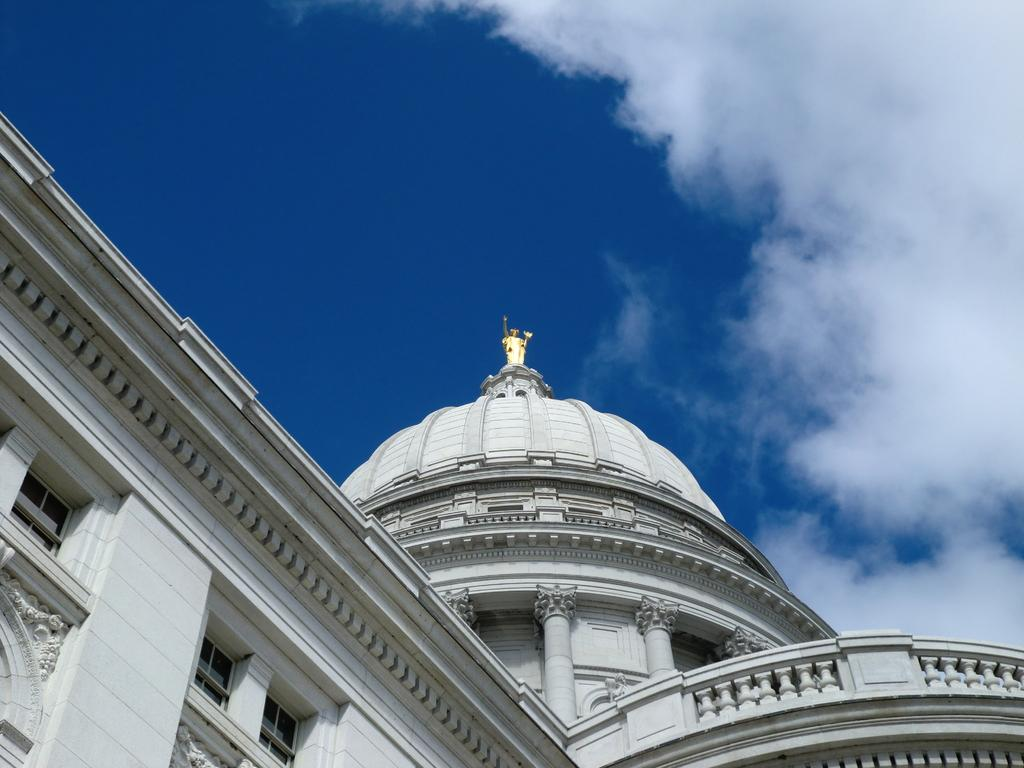What is located on the building in the image? There is a statue on a building in the image. What can be seen in the background of the image? The sky is visible in the background of the image. What is the condition of the sky in the image? Clouds are present in the sky. How long does it take for the toad to reach the statue in the image? There is no toad present in the image, so it is not possible to determine how long it would take for a toad to reach the statue. 